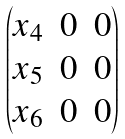<formula> <loc_0><loc_0><loc_500><loc_500>\begin{pmatrix} x _ { 4 } & 0 & 0 \\ x _ { 5 } & 0 & 0 \\ x _ { 6 } & 0 & 0 \end{pmatrix}</formula> 